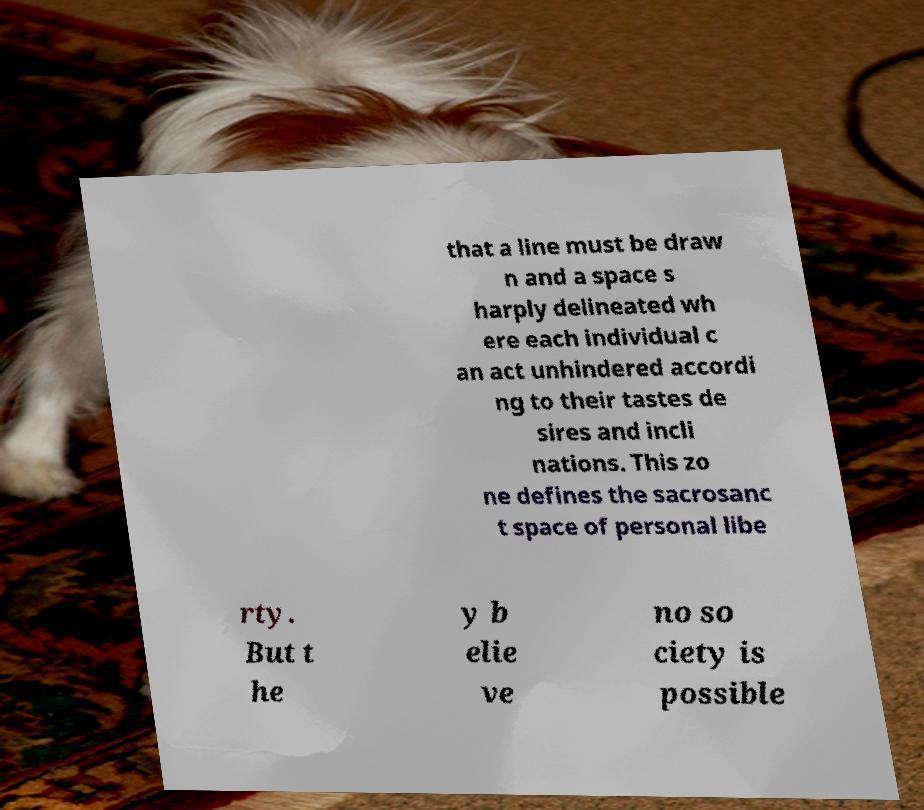There's text embedded in this image that I need extracted. Can you transcribe it verbatim? that a line must be draw n and a space s harply delineated wh ere each individual c an act unhindered accordi ng to their tastes de sires and incli nations. This zo ne defines the sacrosanc t space of personal libe rty. But t he y b elie ve no so ciety is possible 